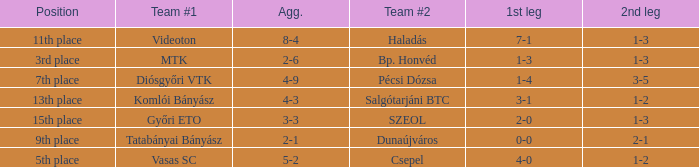Can you give me this table as a dict? {'header': ['Position', 'Team #1', 'Agg.', 'Team #2', '1st leg', '2nd leg'], 'rows': [['11th place', 'Videoton', '8-4', 'Haladás', '7-1', '1-3'], ['3rd place', 'MTK', '2-6', 'Bp. Honvéd', '1-3', '1-3'], ['7th place', 'Diósgyőri VTK', '4-9', 'Pécsi Dózsa', '1-4', '3-5'], ['13th place', 'Komlói Bányász', '4-3', 'Salgótarjáni BTC', '3-1', '1-2'], ['15th place', 'Győri ETO', '3-3', 'SZEOL', '2-0', '1-3'], ['9th place', 'Tatabányai Bányász', '2-1', 'Dunaújváros', '0-0', '2-1'], ['5th place', 'Vasas SC', '5-2', 'Csepel', '4-0', '1-2']]} What is the 1st leg of bp. honvéd team #2? 1-3. 